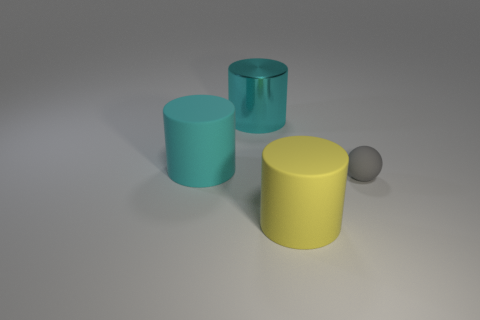Subtract all large rubber cylinders. How many cylinders are left? 1 Add 4 tiny cyan spheres. How many objects exist? 8 Subtract all yellow cylinders. How many cylinders are left? 2 Subtract all gray spheres. How many cyan cylinders are left? 2 Add 4 cyan metal blocks. How many cyan metal blocks exist? 4 Subtract 0 purple cylinders. How many objects are left? 4 Subtract all balls. How many objects are left? 3 Subtract all purple balls. Subtract all blue blocks. How many balls are left? 1 Subtract all rubber objects. Subtract all yellow objects. How many objects are left? 0 Add 2 gray matte balls. How many gray matte balls are left? 3 